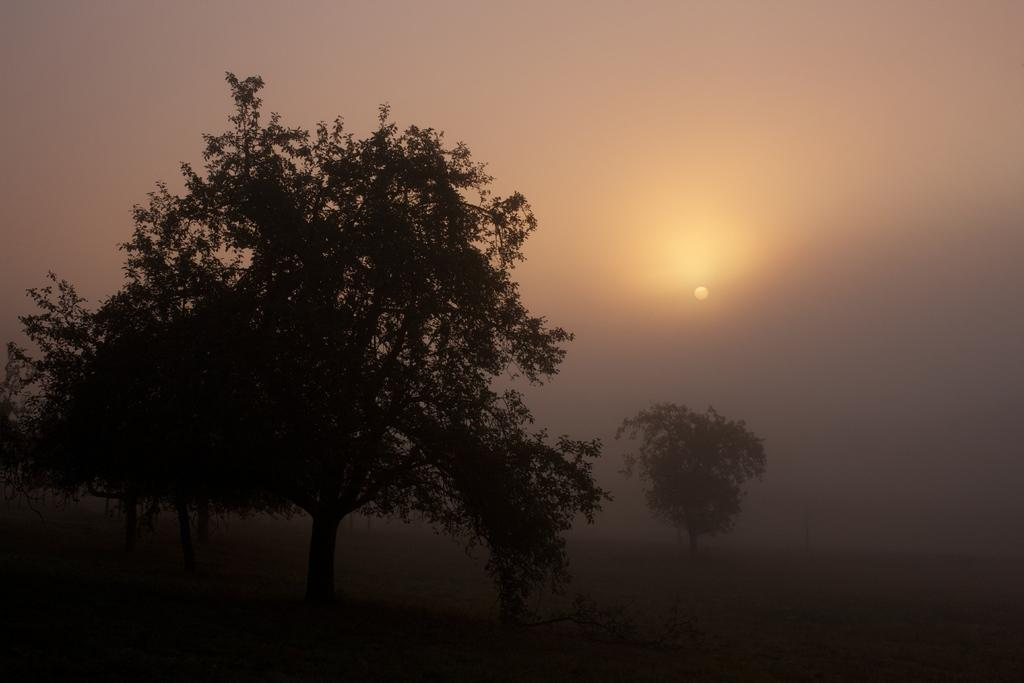What is located in the center of the image? There are trees in the center of the image. What can be seen in the background of the image? The sun and the sky are visible in the background of the image. How many jars of jam are on the trees in the image? There are no jars of jam present in the image; it features trees without any visible jars of jam. What type of transport can be seen in the image? There is no transport visible in the image; it only features trees, the sun, and the sky. 